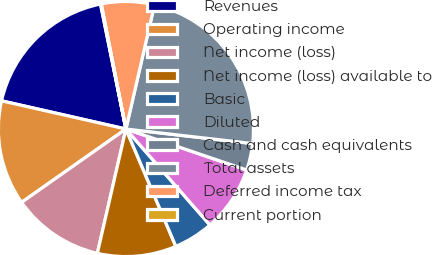<chart> <loc_0><loc_0><loc_500><loc_500><pie_chart><fcel>Revenues<fcel>Operating income<fcel>Net income (loss)<fcel>Net income (loss) available to<fcel>Basic<fcel>Diluted<fcel>Cash and cash equivalents<fcel>Total assets<fcel>Deferred income tax<fcel>Current portion<nl><fcel>18.26%<fcel>13.3%<fcel>11.65%<fcel>10.0%<fcel>5.04%<fcel>8.35%<fcel>3.39%<fcel>23.22%<fcel>6.7%<fcel>0.09%<nl></chart> 